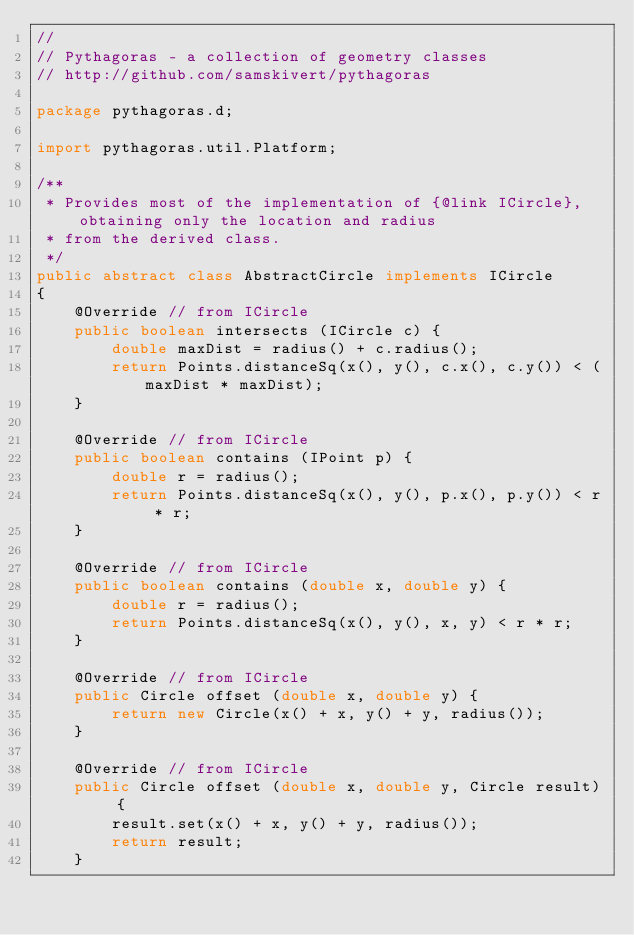<code> <loc_0><loc_0><loc_500><loc_500><_Java_>//
// Pythagoras - a collection of geometry classes
// http://github.com/samskivert/pythagoras

package pythagoras.d;

import pythagoras.util.Platform;

/**
 * Provides most of the implementation of {@link ICircle}, obtaining only the location and radius
 * from the derived class.
 */
public abstract class AbstractCircle implements ICircle
{
    @Override // from ICircle
    public boolean intersects (ICircle c) {
        double maxDist = radius() + c.radius();
        return Points.distanceSq(x(), y(), c.x(), c.y()) < (maxDist * maxDist);
    }

    @Override // from ICircle
    public boolean contains (IPoint p) {
        double r = radius();
        return Points.distanceSq(x(), y(), p.x(), p.y()) < r * r;
    }

    @Override // from ICircle
    public boolean contains (double x, double y) {
        double r = radius();
        return Points.distanceSq(x(), y(), x, y) < r * r;
    }

    @Override // from ICircle
    public Circle offset (double x, double y) {
        return new Circle(x() + x, y() + y, radius());
    }

    @Override // from ICircle
    public Circle offset (double x, double y, Circle result) {
        result.set(x() + x, y() + y, radius());
        return result;
    }
</code> 